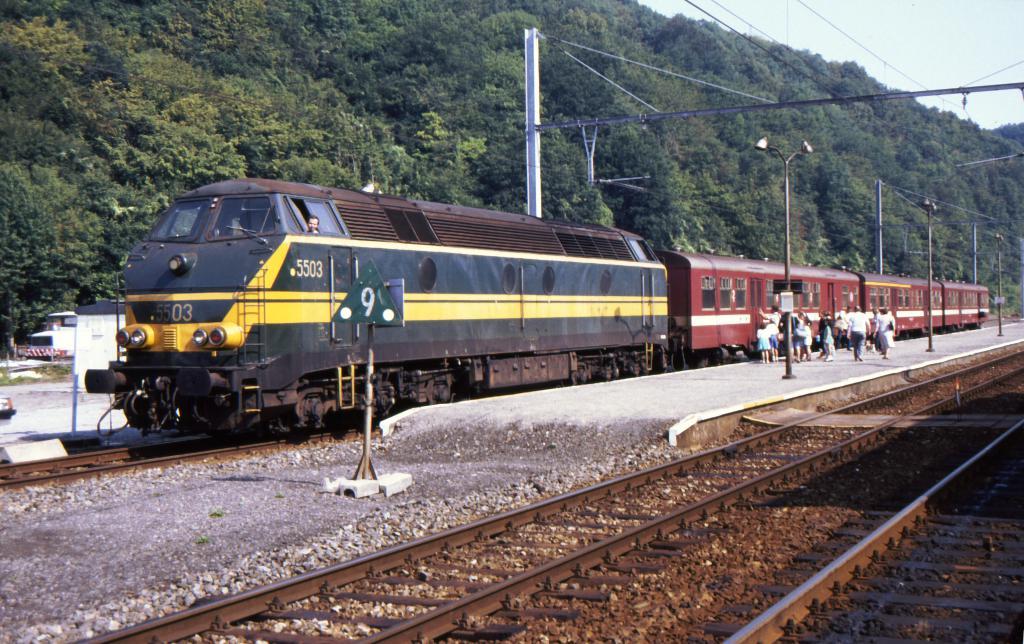What are the 4 digit numbers on the train?
Your answer should be very brief. 5503. What number is on the front of the train?
Provide a short and direct response. 5503. 